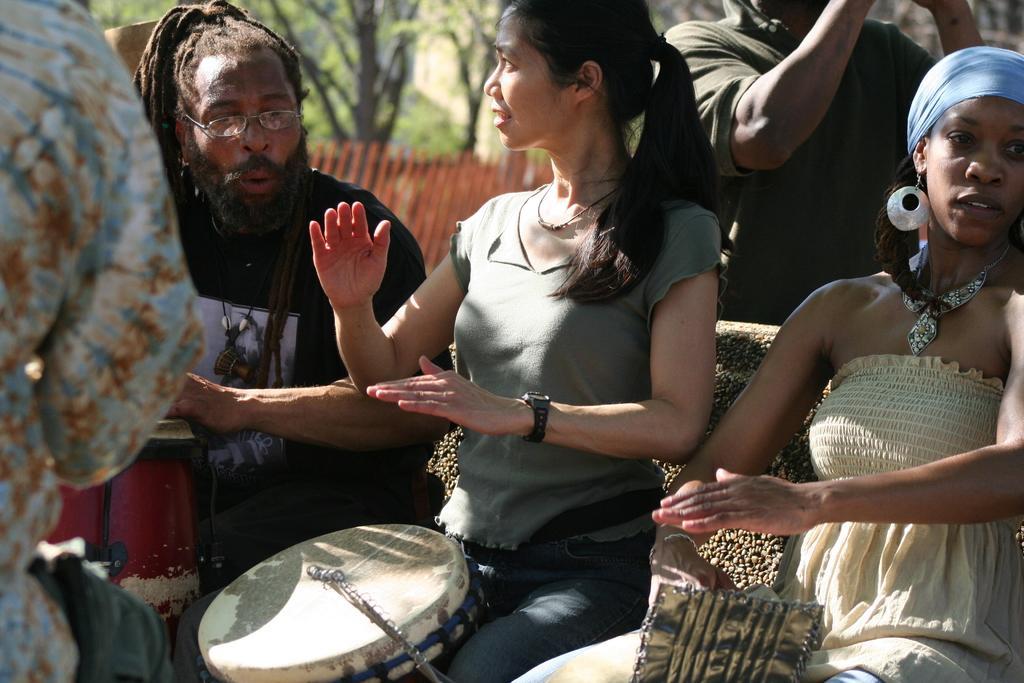In one or two sentences, can you explain what this image depicts? A woman is and playing the drums. Beside her a man with a beard and long hair is playing drums and singing. There is another woman to the right side of the image. There are two people surrounding these three people. 